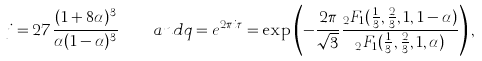<formula> <loc_0><loc_0><loc_500><loc_500>j = 2 7 \frac { ( 1 + 8 \alpha ) ^ { 3 } } { \alpha ( 1 - \alpha ) ^ { 3 } } \quad a n d q = e ^ { 2 \pi i \tau } = \exp \left ( - \frac { 2 \pi } { \sqrt { 3 } } \frac { _ { 2 } F _ { 1 } ( \frac { 1 } { 3 } , \frac { 2 } { 3 } , 1 , 1 - \alpha ) } { _ { 2 } F _ { 1 } ( \frac { 1 } { 3 } , \frac { 2 } { 3 } , 1 , \alpha ) } \right ) ,</formula> 